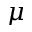Convert formula to latex. <formula><loc_0><loc_0><loc_500><loc_500>\mu</formula> 